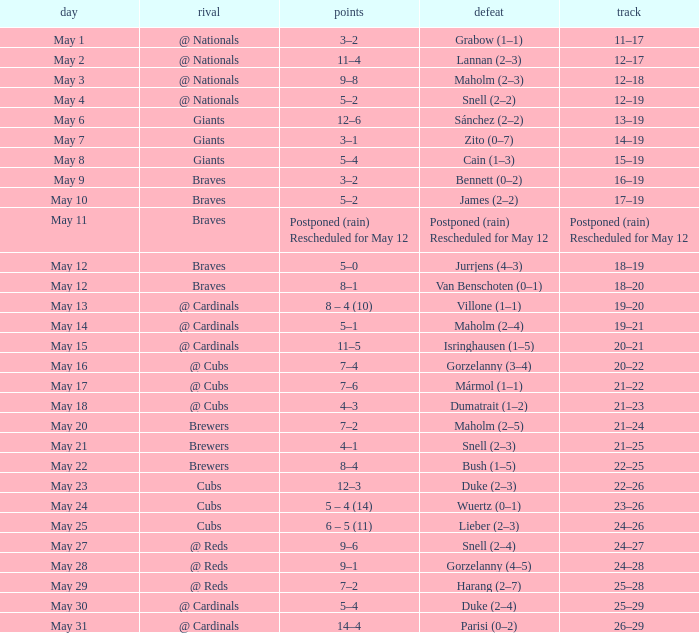What was the score of the game with a loss of Maholm (2–4)? 5–1. 